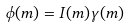Convert formula to latex. <formula><loc_0><loc_0><loc_500><loc_500>\phi ( m ) = I ( m ) \gamma ( m )</formula> 